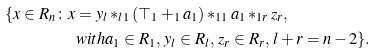Convert formula to latex. <formula><loc_0><loc_0><loc_500><loc_500>\{ x \in R _ { n } \colon x & = y _ { l } \ast _ { l 1 } ( \top _ { 1 } + _ { 1 } a _ { 1 } ) \ast _ { 1 1 } a _ { 1 } \ast _ { 1 r } z _ { r } , \\ & w i t h a _ { 1 } \in R _ { 1 } , \, y _ { l } \in R _ { l } , \, z _ { r } \in R _ { r } , \, l + r = n - 2 \} .</formula> 